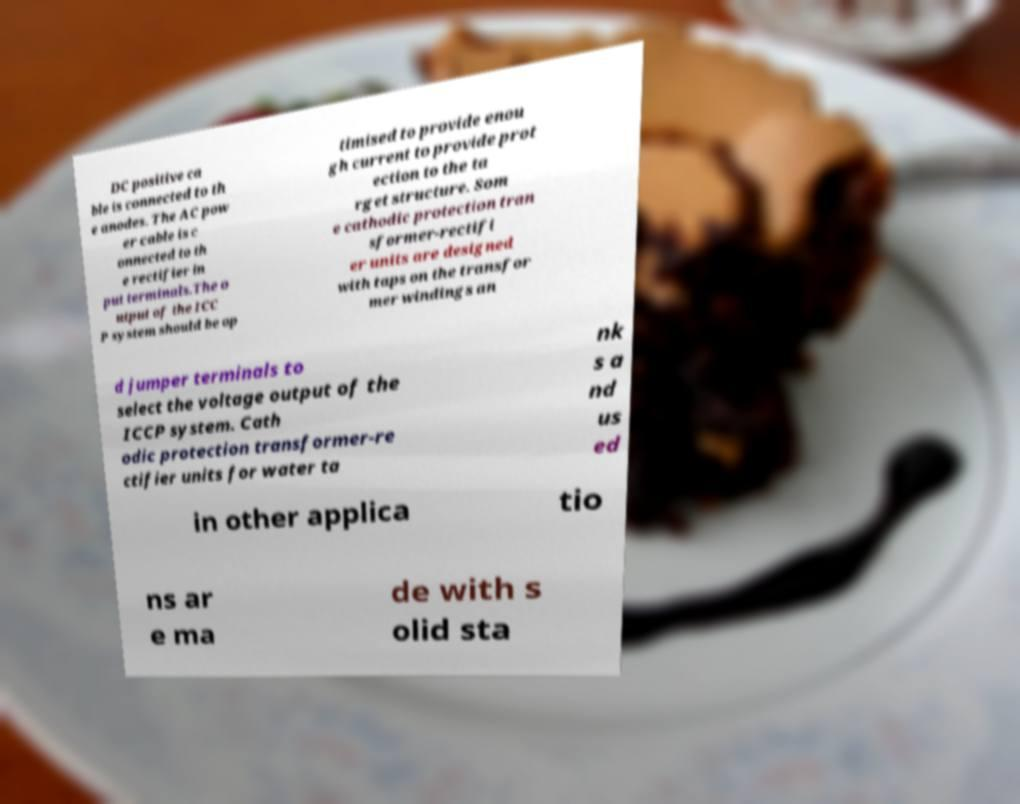I need the written content from this picture converted into text. Can you do that? DC positive ca ble is connected to th e anodes. The AC pow er cable is c onnected to th e rectifier in put terminals.The o utput of the ICC P system should be op timised to provide enou gh current to provide prot ection to the ta rget structure. Som e cathodic protection tran sformer-rectifi er units are designed with taps on the transfor mer windings an d jumper terminals to select the voltage output of the ICCP system. Cath odic protection transformer-re ctifier units for water ta nk s a nd us ed in other applica tio ns ar e ma de with s olid sta 